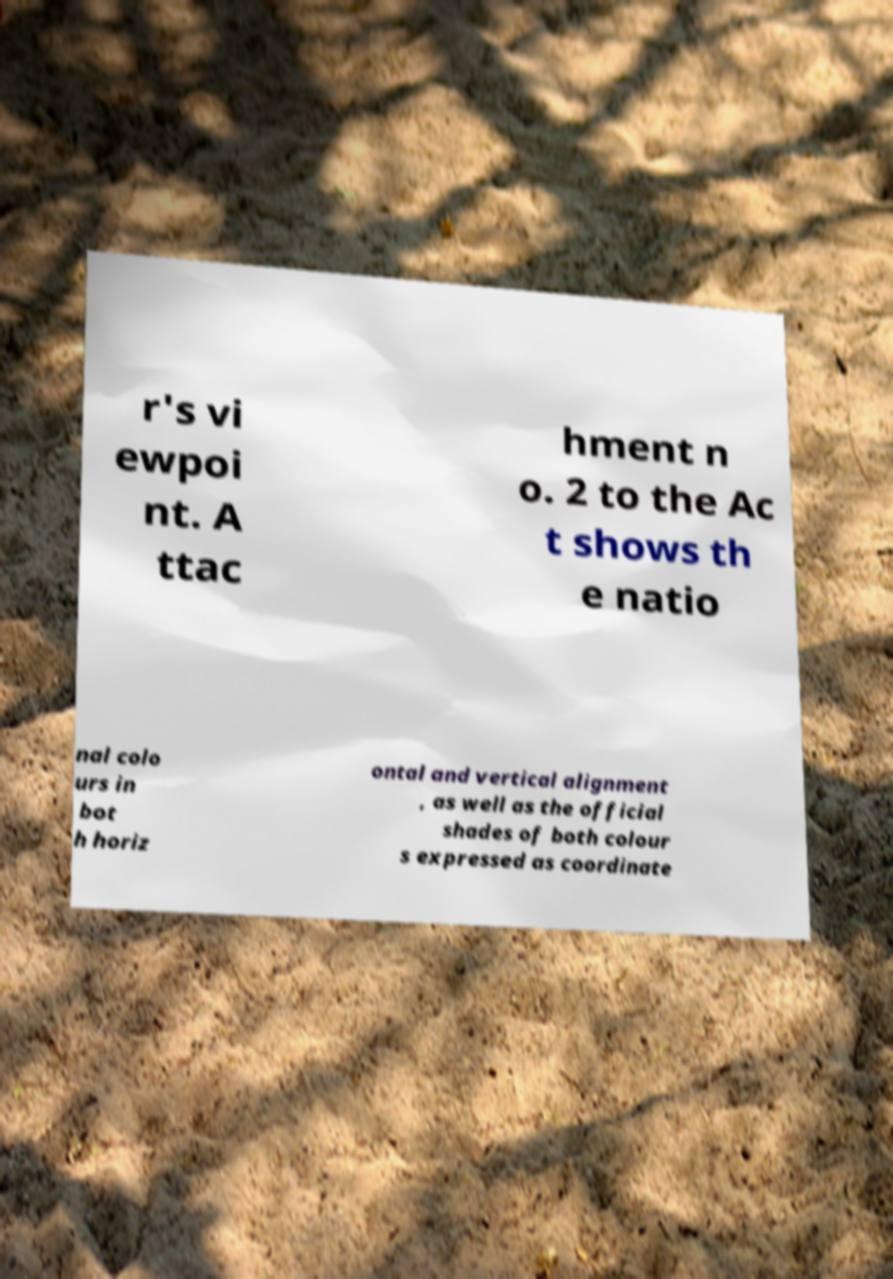Please identify and transcribe the text found in this image. r's vi ewpoi nt. A ttac hment n o. 2 to the Ac t shows th e natio nal colo urs in bot h horiz ontal and vertical alignment , as well as the official shades of both colour s expressed as coordinate 